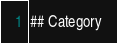Convert code to text. <code><loc_0><loc_0><loc_500><loc_500><_HTML_>## Category
</code> 